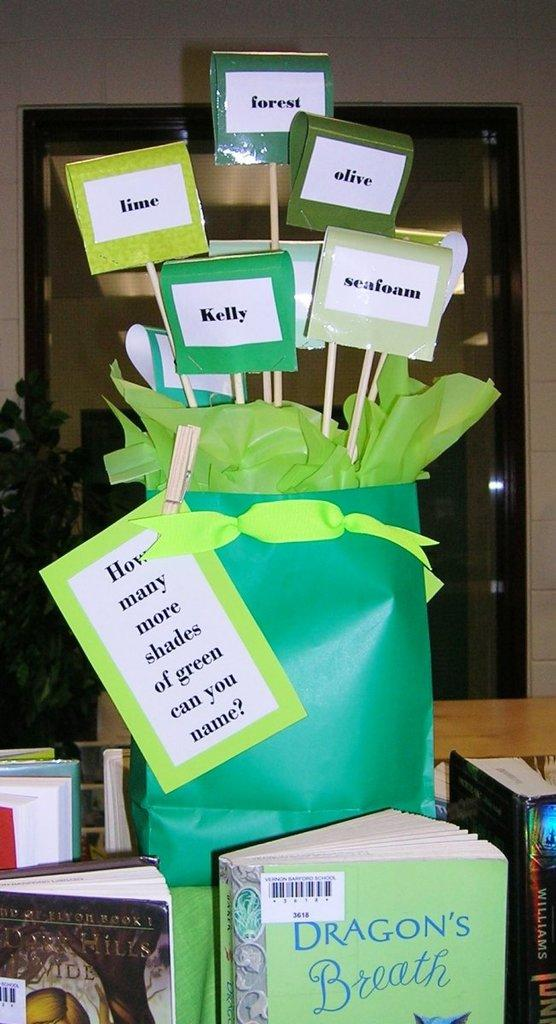<image>
Present a compact description of the photo's key features. A book titled Dragon's Breath is under a green bag. 